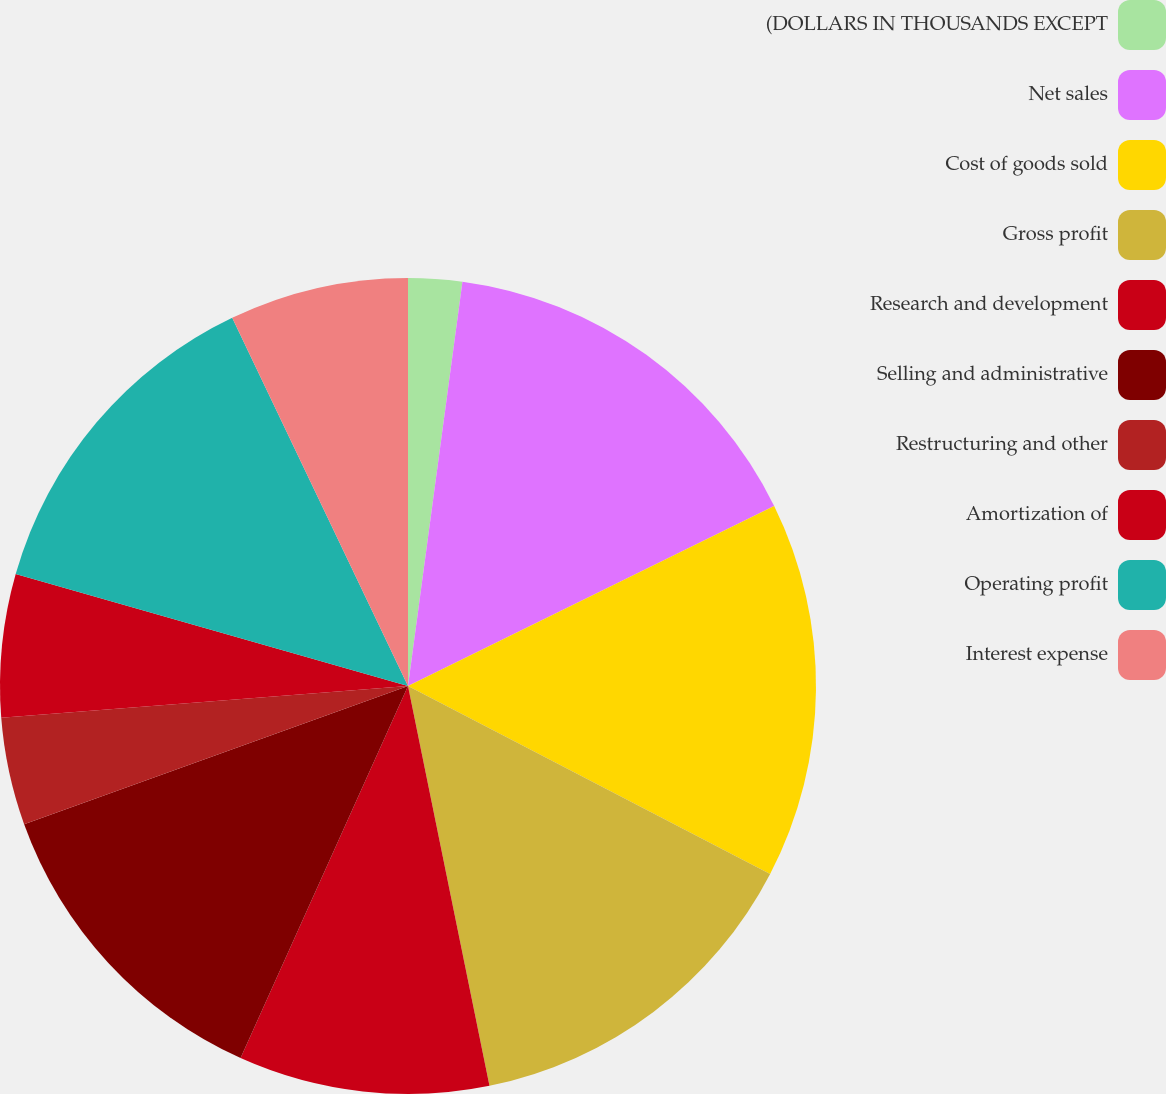Convert chart to OTSL. <chart><loc_0><loc_0><loc_500><loc_500><pie_chart><fcel>(DOLLARS IN THOUSANDS EXCEPT<fcel>Net sales<fcel>Cost of goods sold<fcel>Gross profit<fcel>Research and development<fcel>Selling and administrative<fcel>Restructuring and other<fcel>Amortization of<fcel>Operating profit<fcel>Interest expense<nl><fcel>2.13%<fcel>15.6%<fcel>14.89%<fcel>14.18%<fcel>9.93%<fcel>12.77%<fcel>4.26%<fcel>5.67%<fcel>13.48%<fcel>7.09%<nl></chart> 